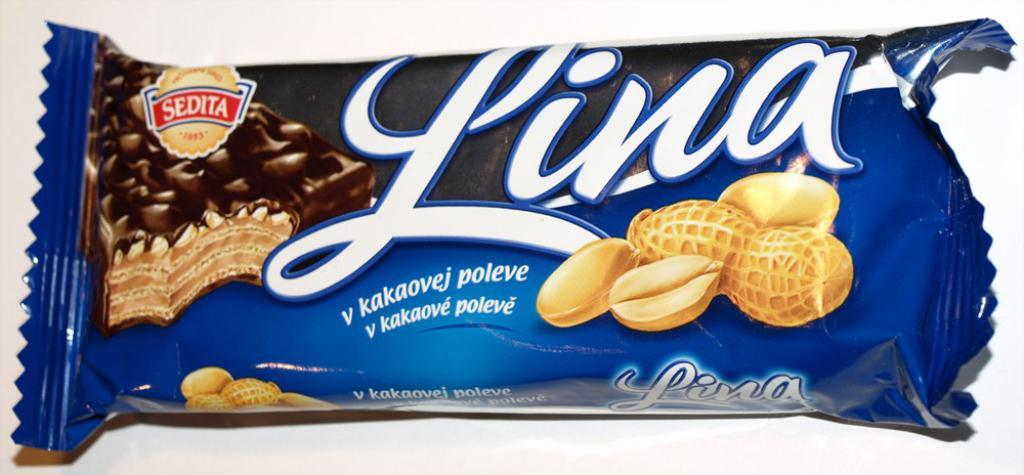What is the main subject of the image? The main subject of the image is a chocolate cover. What can be seen on the chocolate cover? There is chocolate and text on the chocolate cover. Are there any additional ingredients visible on the chocolate cover? Yes, there are groundnuts on the chocolate cover. What color is the background of the image? The background of the image is white. What type of class is being held in the image? There is no class or any indication of a class being held in the image; it features a chocolate cover. Can you see any mist or fog in the image? There is no mist or fog visible in the image; it has a white background. 